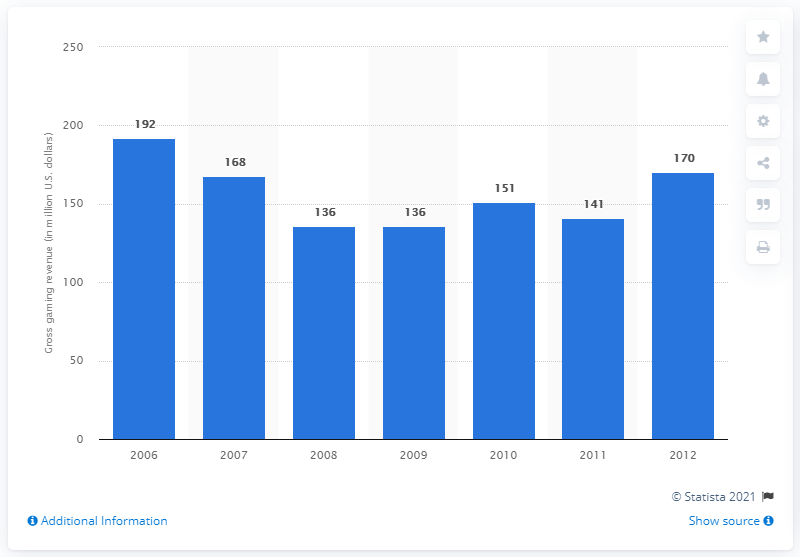Specify some key components in this picture. In 2007, Nevada's total gaming revenue was $168,000,000. 